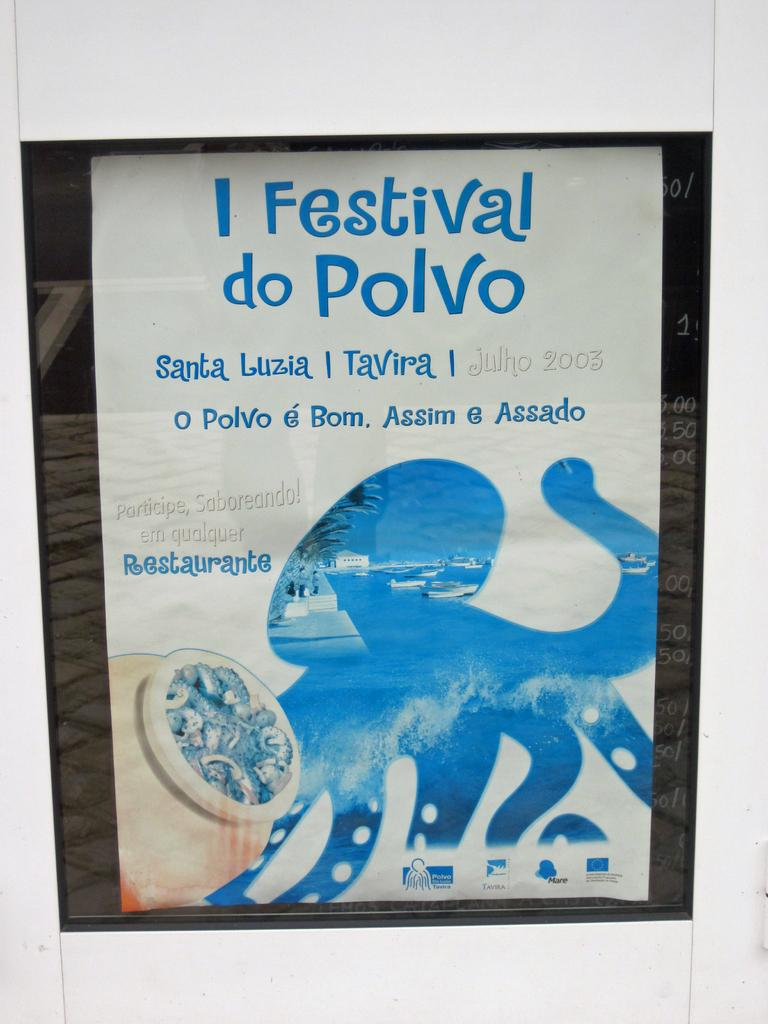What is the main subject in the center of the image? There is a poster in the center of the image. How many kittens are listed on the poster in the image? There is no list or kittens present on the poster in the image. 